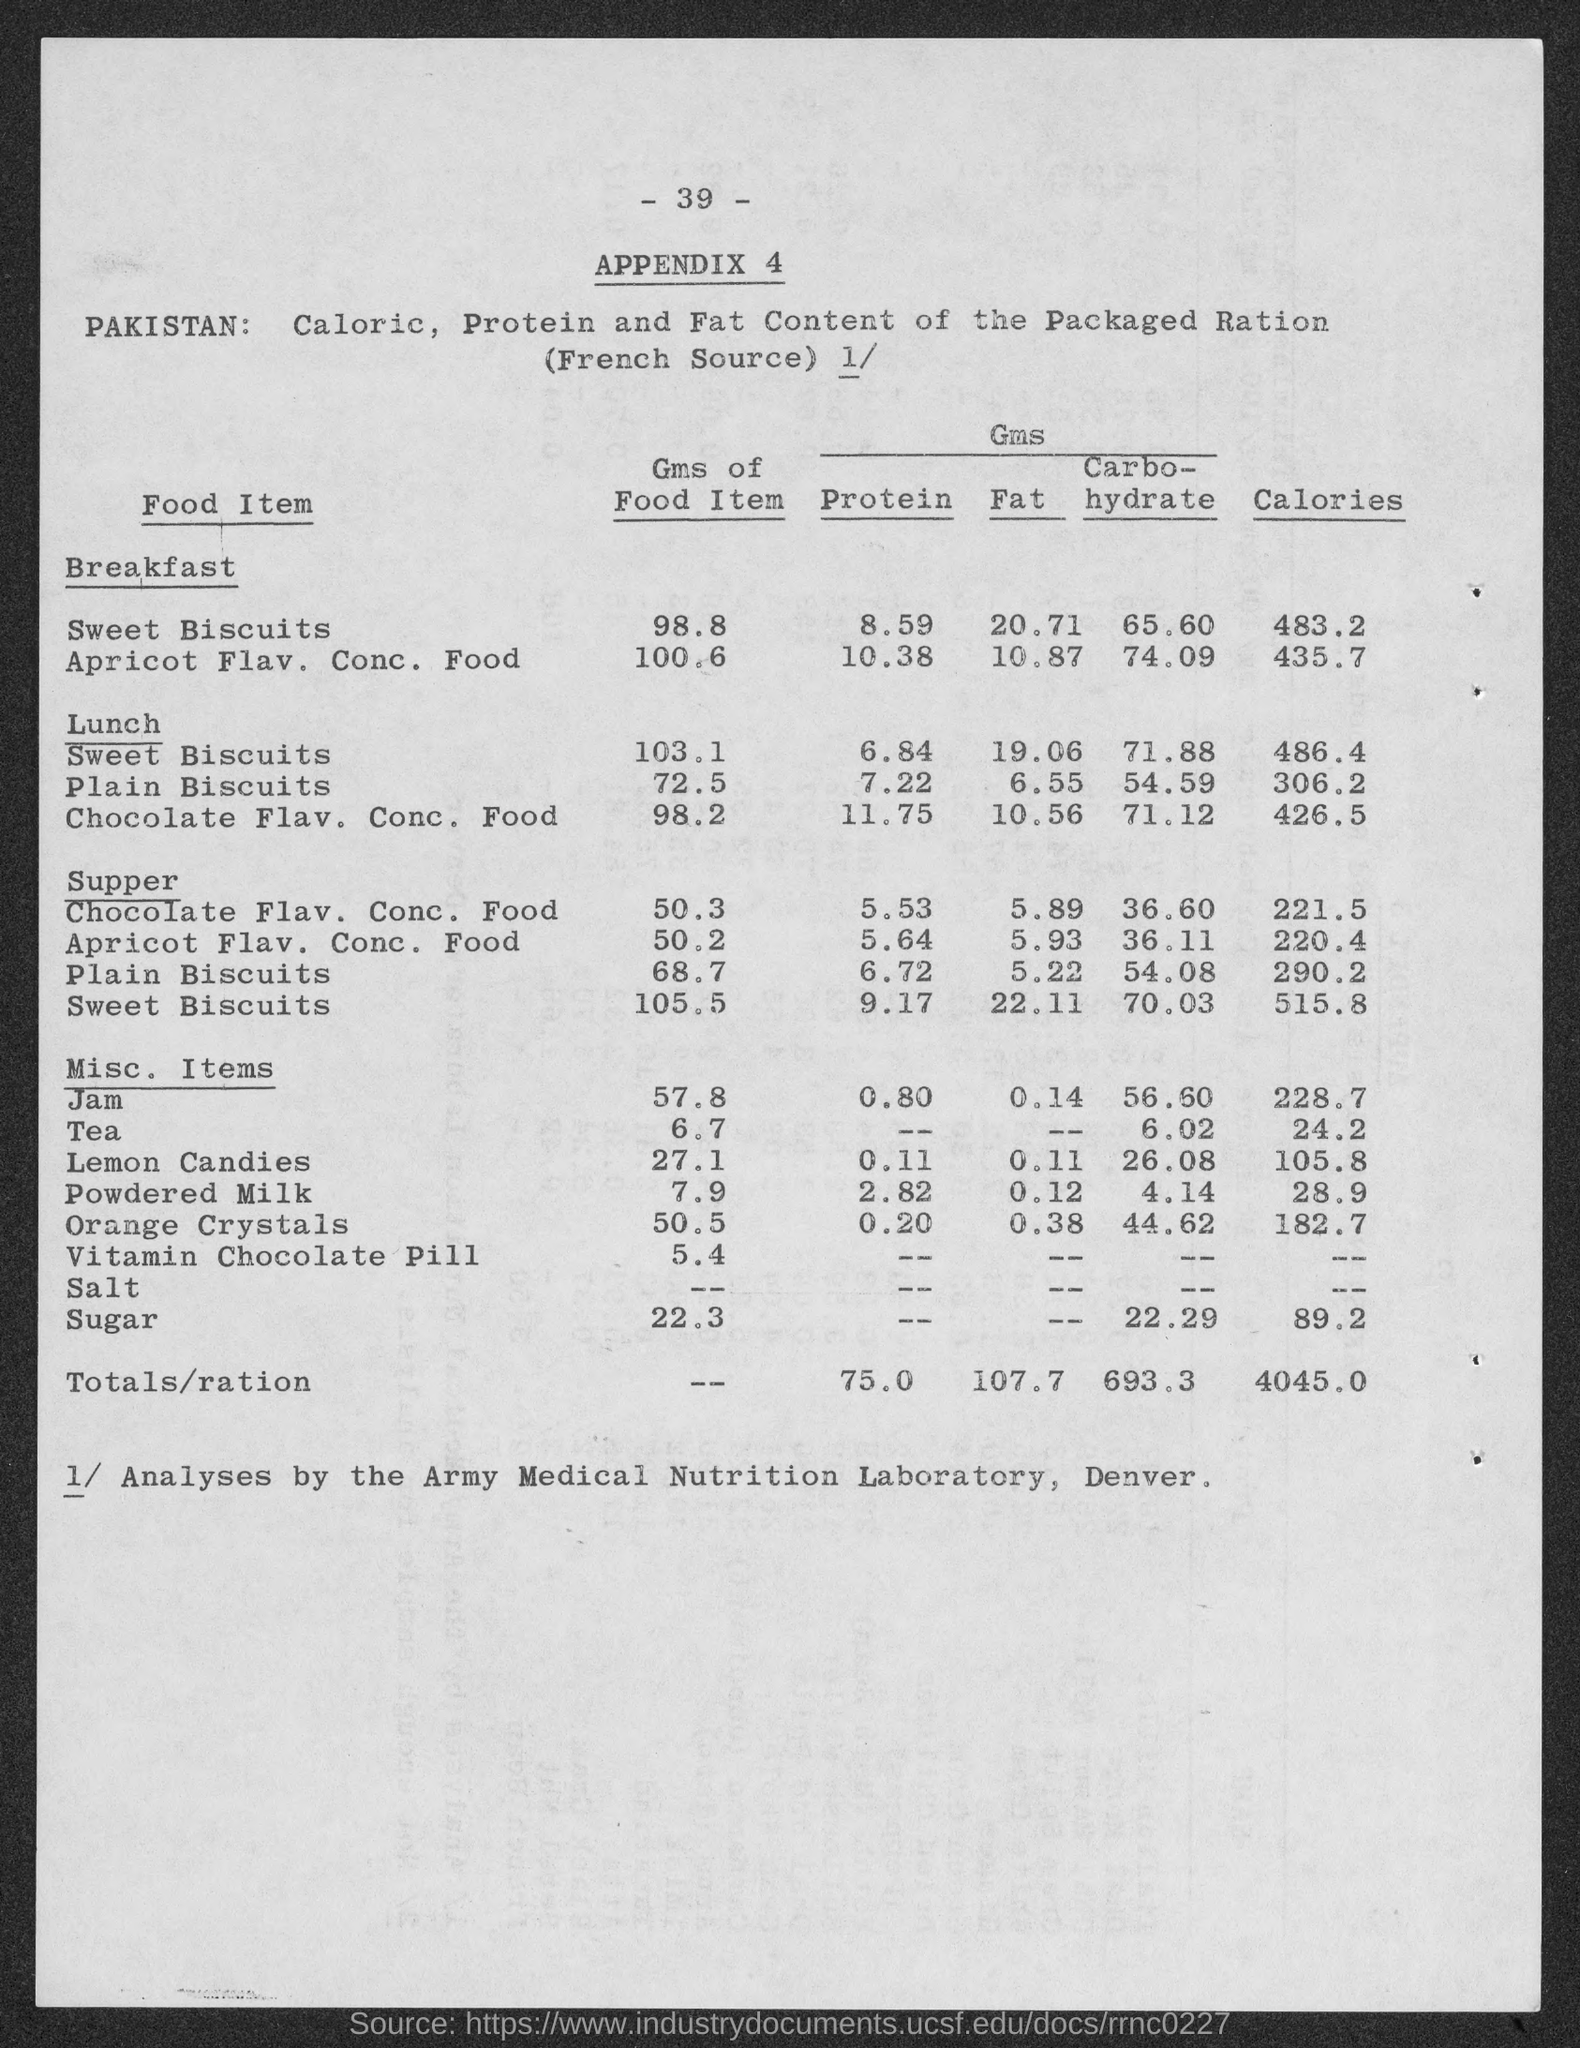Point out several critical features in this image. The number at the top of the page is -39, and... 